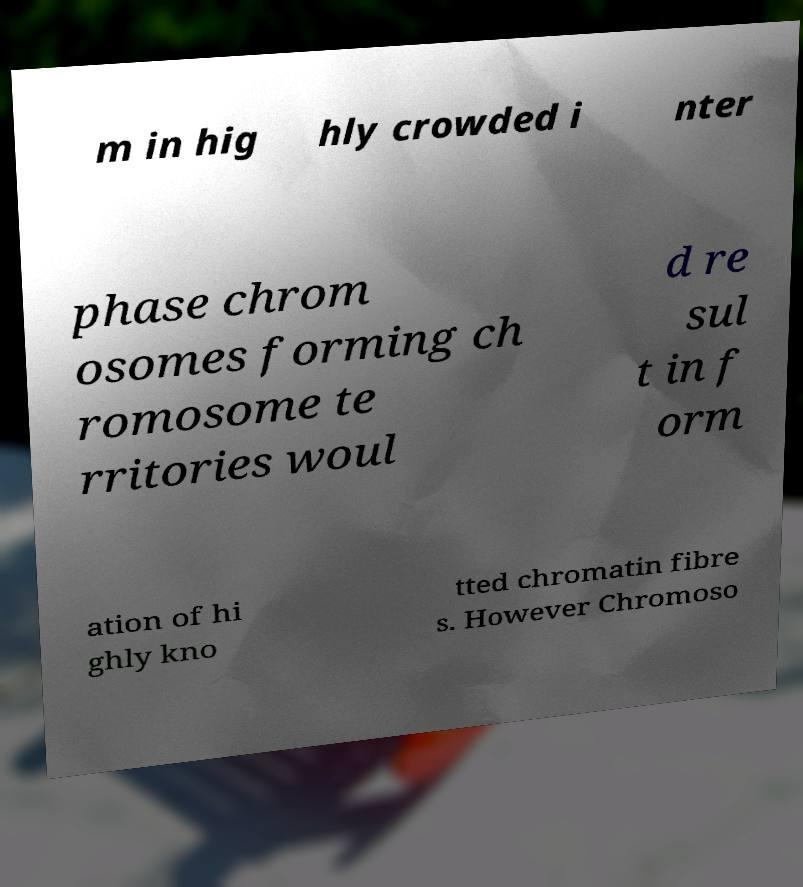Please read and relay the text visible in this image. What does it say? m in hig hly crowded i nter phase chrom osomes forming ch romosome te rritories woul d re sul t in f orm ation of hi ghly kno tted chromatin fibre s. However Chromoso 